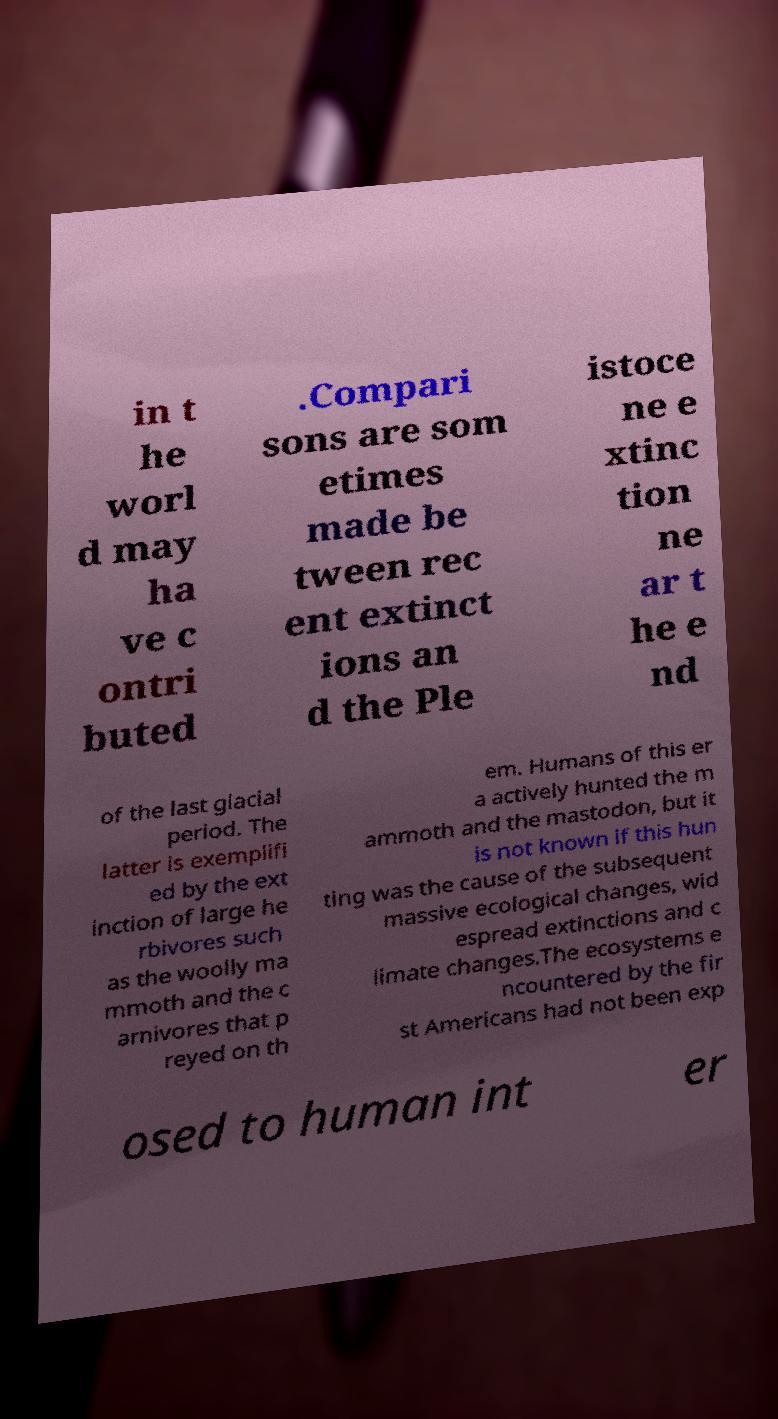There's text embedded in this image that I need extracted. Can you transcribe it verbatim? in t he worl d may ha ve c ontri buted .Compari sons are som etimes made be tween rec ent extinct ions an d the Ple istoce ne e xtinc tion ne ar t he e nd of the last glacial period. The latter is exemplifi ed by the ext inction of large he rbivores such as the woolly ma mmoth and the c arnivores that p reyed on th em. Humans of this er a actively hunted the m ammoth and the mastodon, but it is not known if this hun ting was the cause of the subsequent massive ecological changes, wid espread extinctions and c limate changes.The ecosystems e ncountered by the fir st Americans had not been exp osed to human int er 